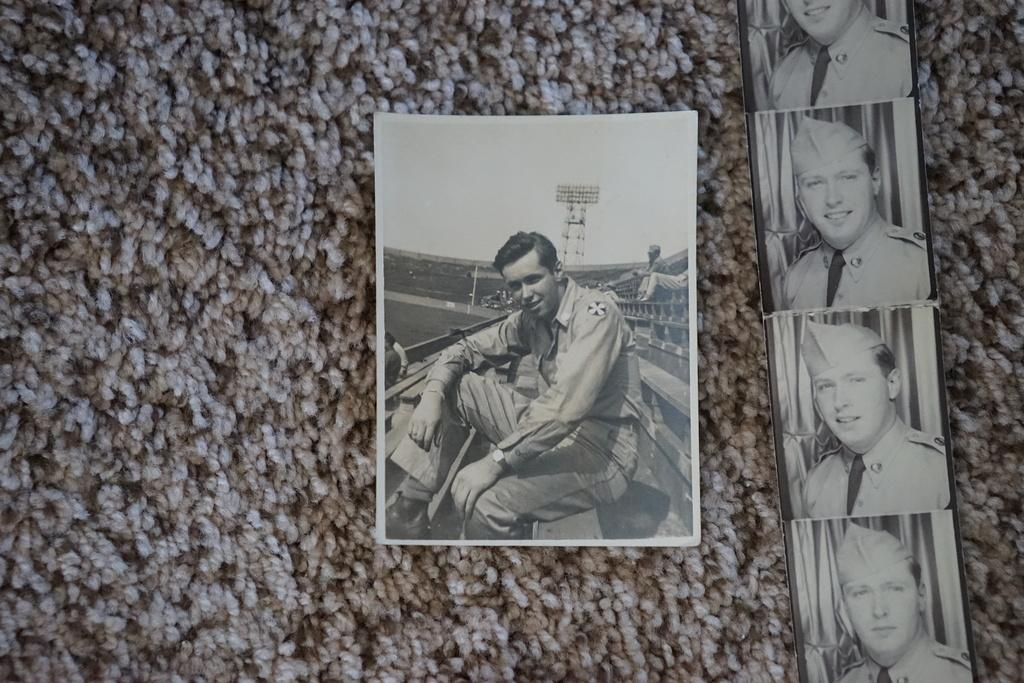What is in the foreground of the image? There are photos in the foreground of the image. What is the surface on which the photos are placed? The photos are on a mat surface. What type of mouth can be seen in the image? There is no mouth present in the image, as it only features photos on a mat surface. 